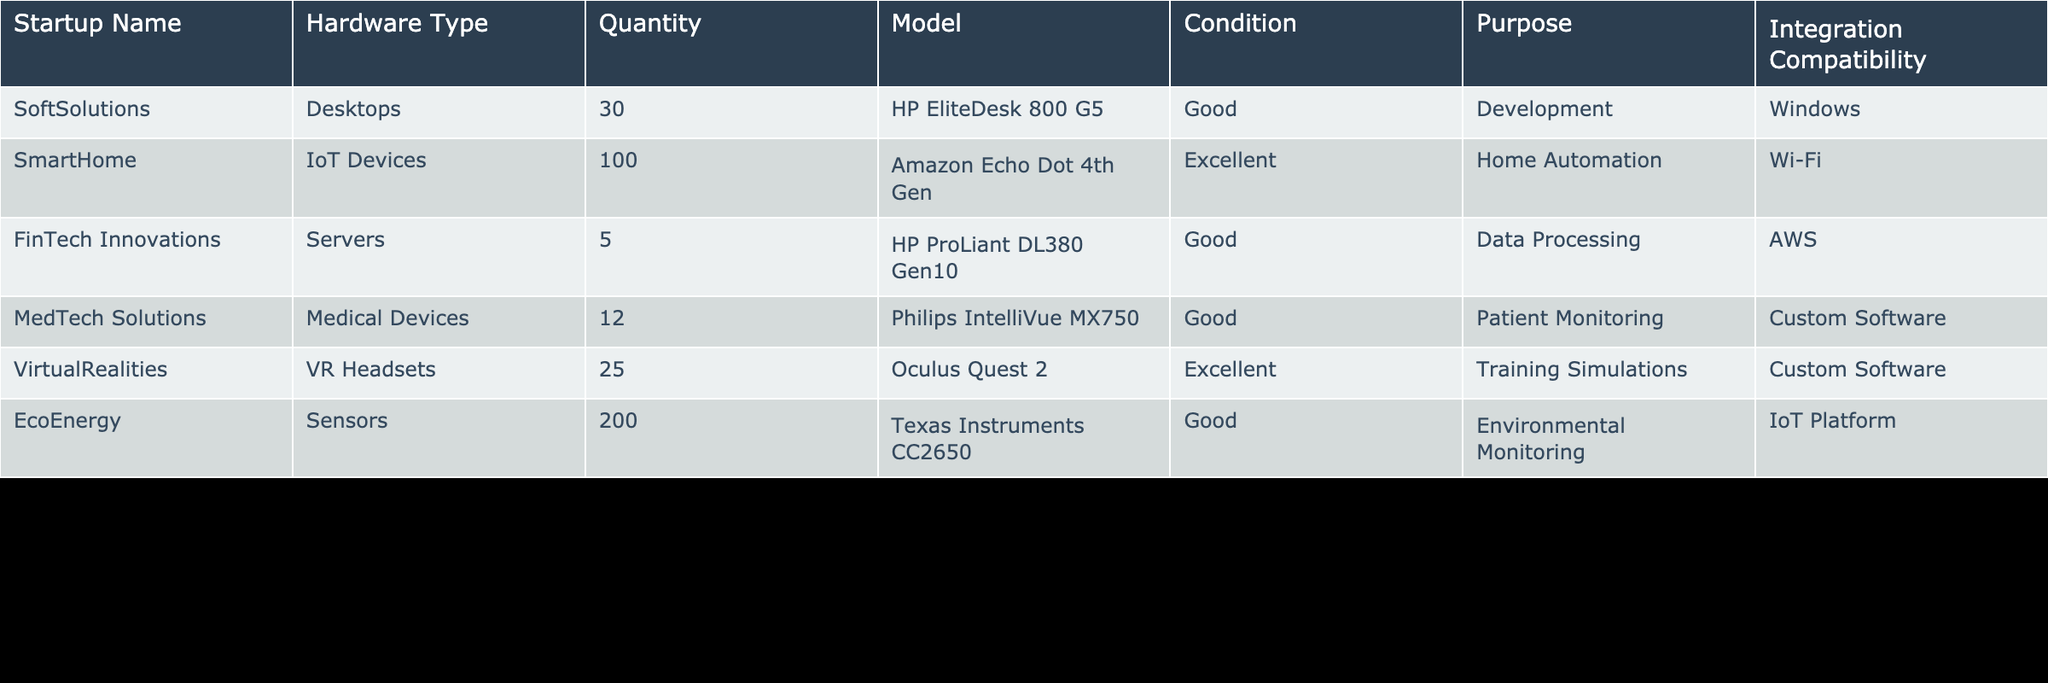What is the total quantity of IoT devices in the inventory? The table lists that SmartHome has 100 IoT devices. Since it is the only startup with this hardware type, the total quantity is simply 100.
Answer: 100 Which startup has the highest quantity of hardware resources? The startup EcoEnergy has 200 sensors, which is the highest quantity among all hardware types listed in the table.
Answer: EcoEnergy Are there any medical devices listed in the inventory? The table shows that MedTech Solutions has 12 medical devices, which confirms that there are medical devices in the inventory.
Answer: Yes What is the average quantity of desktops listed in the inventory? SoftSolutions is the only startup with desktops, listing a quantity of 30. Therefore, the average quantity of desktops is 30/1 = 30.
Answer: 30 Which hardware type is the most common in the inventory based on quantity? The hardware type sensors from EcoEnergy has the highest quantity at 200, making it the most common hardware type listed in the inventory.
Answer: Sensors Do any of the startups have "Excellent" condition hardware? The table shows that both SmartHome (IoT Devices) and VirtualRealities (VR Headsets) have hardware in "Excellent" condition, indicating that at least two startups do have such condition.
Answer: Yes How many total servers are available across the companies listed? The only startup with servers is FinTech Innovations, which has 5 servers. Therefore, the total number of servers in the inventory is just 5.
Answer: 5 What is the total quantity of hardware resources in the inventory across all startups? Summing up the quantities of hardware from all startups gives: 30 (Desktops) + 100 (IoT Devices) + 5 (Servers) + 12 (Medical Devices) + 25 (VR Headsets) + 200 (Sensors) = 372. So, the total quantity is 372.
Answer: 372 Identify all startups that have custom software compatibility. MedTech Solutions (Medical Devices) and VirtualRealities (VR Headsets) are both listed as having custom software compatibility. Hence, the startups with this compatibility are MedTech Solutions and VirtualRealities.
Answer: MedTech Solutions, VirtualRealities 